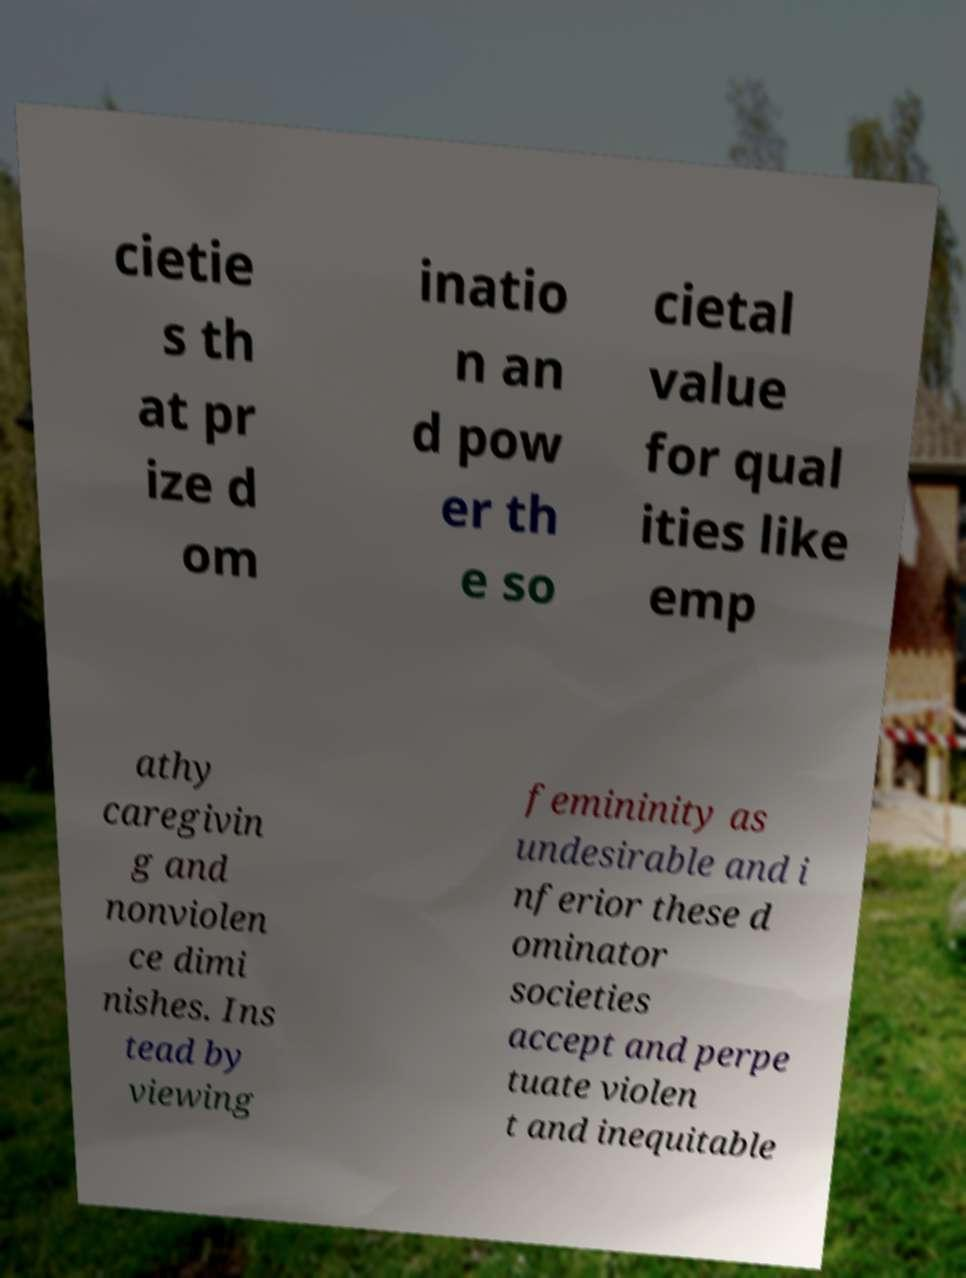Can you accurately transcribe the text from the provided image for me? cietie s th at pr ize d om inatio n an d pow er th e so cietal value for qual ities like emp athy caregivin g and nonviolen ce dimi nishes. Ins tead by viewing femininity as undesirable and i nferior these d ominator societies accept and perpe tuate violen t and inequitable 